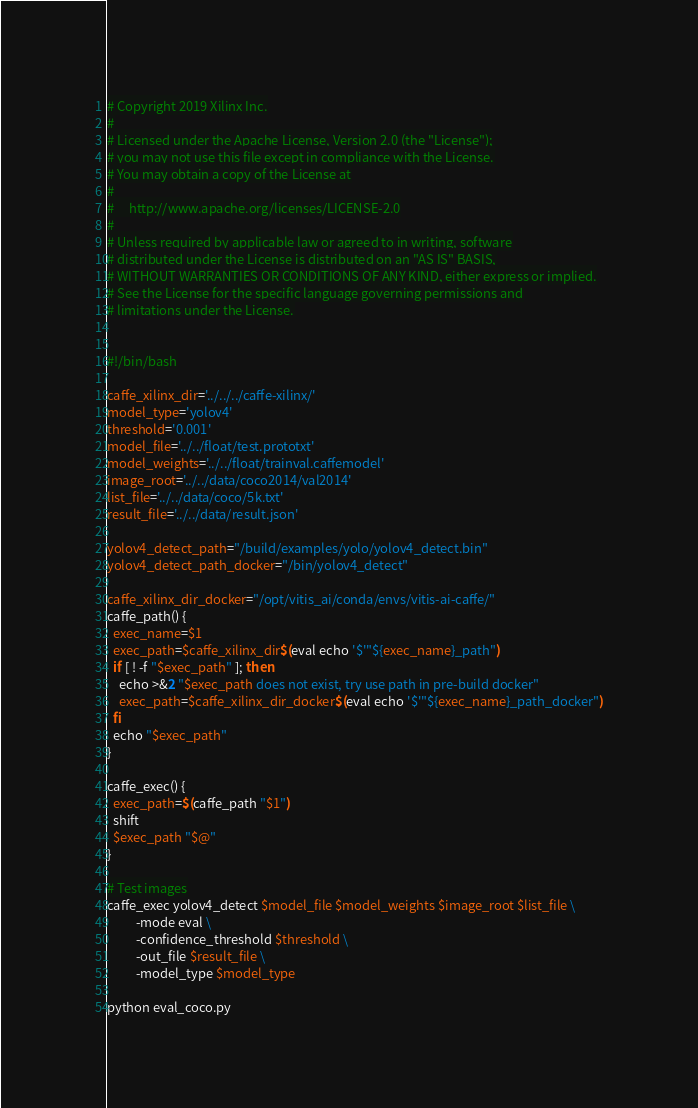<code> <loc_0><loc_0><loc_500><loc_500><_Bash_># Copyright 2019 Xilinx Inc.
#
# Licensed under the Apache License, Version 2.0 (the "License");
# you may not use this file except in compliance with the License.
# You may obtain a copy of the License at
#
#     http://www.apache.org/licenses/LICENSE-2.0
#
# Unless required by applicable law or agreed to in writing, software
# distributed under the License is distributed on an "AS IS" BASIS,
# WITHOUT WARRANTIES OR CONDITIONS OF ANY KIND, either express or implied.
# See the License for the specific language governing permissions and
# limitations under the License.


#!/bin/bash

caffe_xilinx_dir='../../../caffe-xilinx/'
model_type='yolov4'
threshold='0.001'
model_file='../../float/test.prototxt'
model_weights='../../float/trainval.caffemodel'
image_root='../../data/coco2014/val2014'
list_file='../../data/coco/5k.txt'
result_file='../../data/result.json'

yolov4_detect_path="/build/examples/yolo/yolov4_detect.bin"
yolov4_detect_path_docker="/bin/yolov4_detect"

caffe_xilinx_dir_docker="/opt/vitis_ai/conda/envs/vitis-ai-caffe/"
caffe_path() {
  exec_name=$1
  exec_path=$caffe_xilinx_dir$(eval echo '$'"${exec_name}_path")
  if [ ! -f "$exec_path" ]; then
    echo >&2 "$exec_path does not exist, try use path in pre-build docker"
    exec_path=$caffe_xilinx_dir_docker$(eval echo '$'"${exec_name}_path_docker")
  fi
  echo "$exec_path"
}

caffe_exec() {
  exec_path=$(caffe_path "$1")
  shift
  $exec_path "$@"
}

# Test images
caffe_exec yolov4_detect $model_file $model_weights $image_root $list_file \
          -mode eval \
          -confidence_threshold $threshold \
          -out_file $result_file \
          -model_type $model_type 

python eval_coco.py
</code> 